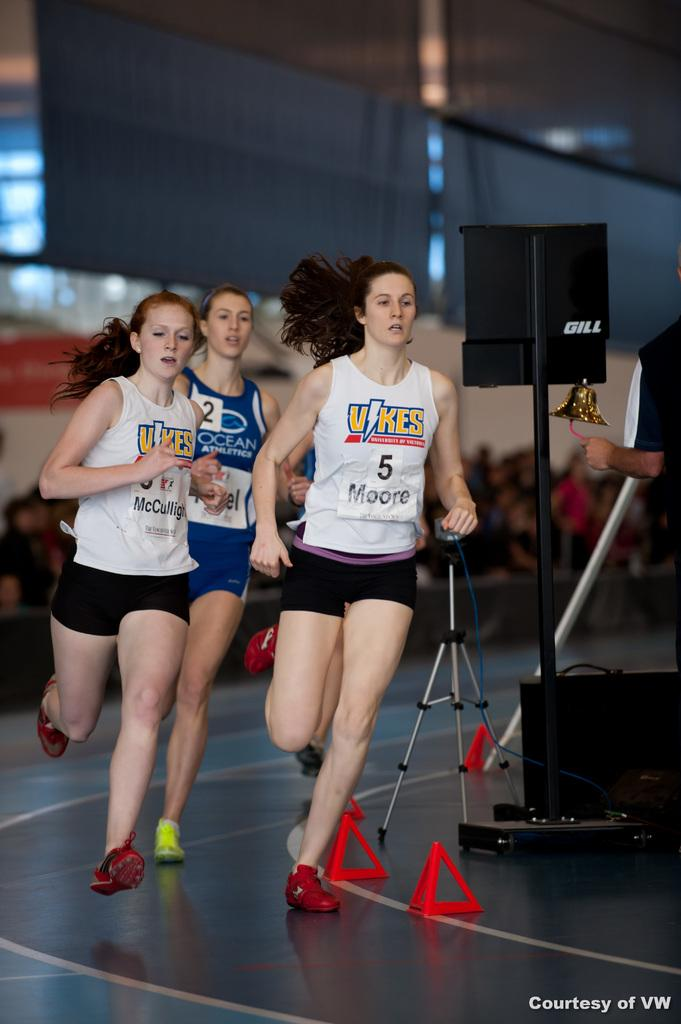Provide a one-sentence caption for the provided image. Two female runners on the Vikes team are running a race and are ahead of the female wearing an Ocean Athletic shirt. 